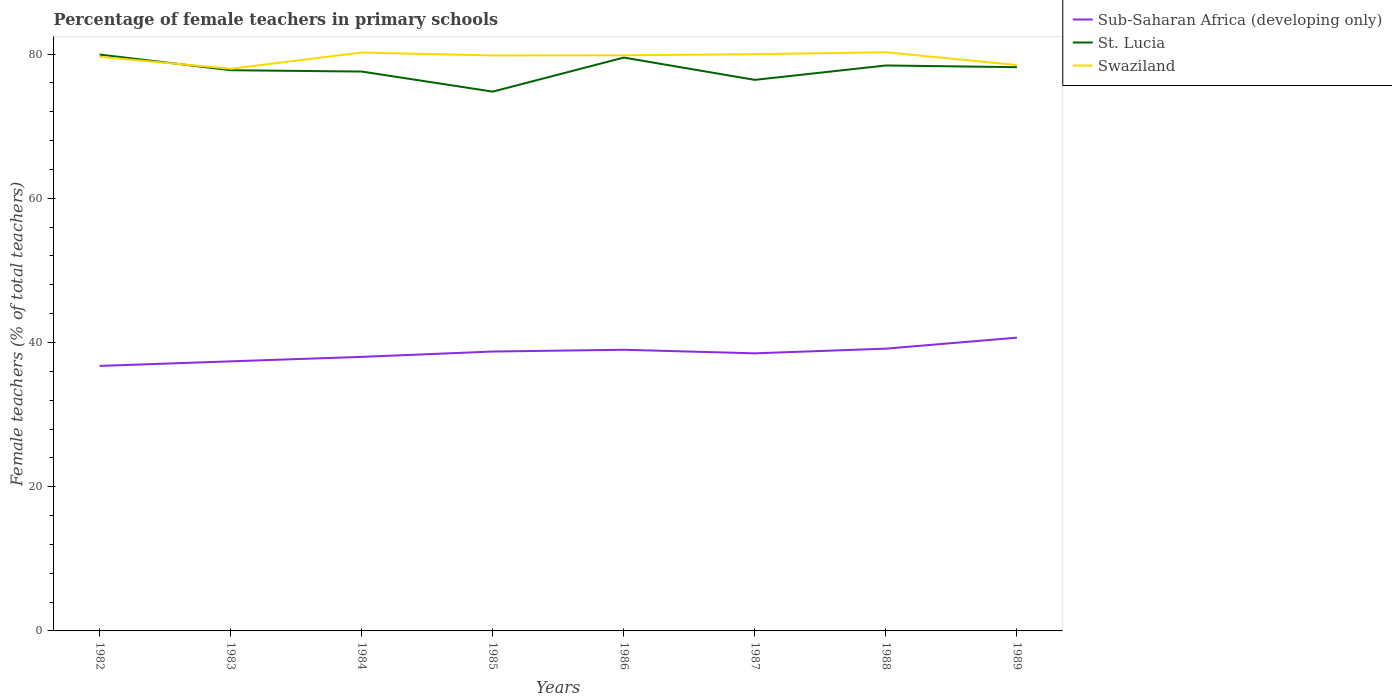Across all years, what is the maximum percentage of female teachers in St. Lucia?
Your response must be concise. 74.8. In which year was the percentage of female teachers in St. Lucia maximum?
Your answer should be very brief. 1985. What is the total percentage of female teachers in Sub-Saharan Africa (developing only) in the graph?
Make the answer very short. -0.4. What is the difference between the highest and the second highest percentage of female teachers in St. Lucia?
Your answer should be very brief. 5.14. Is the percentage of female teachers in Sub-Saharan Africa (developing only) strictly greater than the percentage of female teachers in Swaziland over the years?
Your response must be concise. Yes. What is the difference between two consecutive major ticks on the Y-axis?
Provide a succinct answer. 20. Are the values on the major ticks of Y-axis written in scientific E-notation?
Offer a very short reply. No. How many legend labels are there?
Your response must be concise. 3. How are the legend labels stacked?
Give a very brief answer. Vertical. What is the title of the graph?
Provide a short and direct response. Percentage of female teachers in primary schools. Does "Guam" appear as one of the legend labels in the graph?
Provide a succinct answer. No. What is the label or title of the Y-axis?
Give a very brief answer. Female teachers (% of total teachers). What is the Female teachers (% of total teachers) of Sub-Saharan Africa (developing only) in 1982?
Your answer should be compact. 36.75. What is the Female teachers (% of total teachers) in St. Lucia in 1982?
Ensure brevity in your answer.  79.94. What is the Female teachers (% of total teachers) in Swaziland in 1982?
Your answer should be compact. 79.62. What is the Female teachers (% of total teachers) of Sub-Saharan Africa (developing only) in 1983?
Keep it short and to the point. 37.39. What is the Female teachers (% of total teachers) in St. Lucia in 1983?
Make the answer very short. 77.77. What is the Female teachers (% of total teachers) of Swaziland in 1983?
Your answer should be very brief. 77.97. What is the Female teachers (% of total teachers) of Sub-Saharan Africa (developing only) in 1984?
Your answer should be very brief. 38.01. What is the Female teachers (% of total teachers) of St. Lucia in 1984?
Give a very brief answer. 77.58. What is the Female teachers (% of total teachers) of Swaziland in 1984?
Your answer should be very brief. 80.22. What is the Female teachers (% of total teachers) in Sub-Saharan Africa (developing only) in 1985?
Ensure brevity in your answer.  38.75. What is the Female teachers (% of total teachers) of St. Lucia in 1985?
Provide a succinct answer. 74.8. What is the Female teachers (% of total teachers) of Swaziland in 1985?
Offer a terse response. 79.81. What is the Female teachers (% of total teachers) in Sub-Saharan Africa (developing only) in 1986?
Your response must be concise. 38.99. What is the Female teachers (% of total teachers) in St. Lucia in 1986?
Offer a very short reply. 79.52. What is the Female teachers (% of total teachers) of Swaziland in 1986?
Make the answer very short. 79.84. What is the Female teachers (% of total teachers) of Sub-Saharan Africa (developing only) in 1987?
Offer a terse response. 38.5. What is the Female teachers (% of total teachers) of St. Lucia in 1987?
Make the answer very short. 76.43. What is the Female teachers (% of total teachers) in Swaziland in 1987?
Your answer should be compact. 79.99. What is the Female teachers (% of total teachers) of Sub-Saharan Africa (developing only) in 1988?
Your answer should be compact. 39.15. What is the Female teachers (% of total teachers) in St. Lucia in 1988?
Offer a terse response. 78.42. What is the Female teachers (% of total teachers) of Swaziland in 1988?
Give a very brief answer. 80.26. What is the Female teachers (% of total teachers) in Sub-Saharan Africa (developing only) in 1989?
Give a very brief answer. 40.67. What is the Female teachers (% of total teachers) of St. Lucia in 1989?
Give a very brief answer. 78.19. What is the Female teachers (% of total teachers) in Swaziland in 1989?
Give a very brief answer. 78.49. Across all years, what is the maximum Female teachers (% of total teachers) of Sub-Saharan Africa (developing only)?
Your response must be concise. 40.67. Across all years, what is the maximum Female teachers (% of total teachers) of St. Lucia?
Offer a terse response. 79.94. Across all years, what is the maximum Female teachers (% of total teachers) in Swaziland?
Ensure brevity in your answer.  80.26. Across all years, what is the minimum Female teachers (% of total teachers) of Sub-Saharan Africa (developing only)?
Make the answer very short. 36.75. Across all years, what is the minimum Female teachers (% of total teachers) of St. Lucia?
Your response must be concise. 74.8. Across all years, what is the minimum Female teachers (% of total teachers) in Swaziland?
Your answer should be very brief. 77.97. What is the total Female teachers (% of total teachers) of Sub-Saharan Africa (developing only) in the graph?
Your answer should be compact. 308.22. What is the total Female teachers (% of total teachers) in St. Lucia in the graph?
Provide a succinct answer. 622.65. What is the total Female teachers (% of total teachers) in Swaziland in the graph?
Your response must be concise. 636.19. What is the difference between the Female teachers (% of total teachers) of Sub-Saharan Africa (developing only) in 1982 and that in 1983?
Ensure brevity in your answer.  -0.63. What is the difference between the Female teachers (% of total teachers) of St. Lucia in 1982 and that in 1983?
Ensure brevity in your answer.  2.17. What is the difference between the Female teachers (% of total teachers) of Swaziland in 1982 and that in 1983?
Make the answer very short. 1.65. What is the difference between the Female teachers (% of total teachers) in Sub-Saharan Africa (developing only) in 1982 and that in 1984?
Offer a terse response. -1.26. What is the difference between the Female teachers (% of total teachers) of St. Lucia in 1982 and that in 1984?
Provide a short and direct response. 2.36. What is the difference between the Female teachers (% of total teachers) of Swaziland in 1982 and that in 1984?
Ensure brevity in your answer.  -0.59. What is the difference between the Female teachers (% of total teachers) of Sub-Saharan Africa (developing only) in 1982 and that in 1985?
Ensure brevity in your answer.  -2. What is the difference between the Female teachers (% of total teachers) in St. Lucia in 1982 and that in 1985?
Provide a succinct answer. 5.14. What is the difference between the Female teachers (% of total teachers) of Swaziland in 1982 and that in 1985?
Make the answer very short. -0.19. What is the difference between the Female teachers (% of total teachers) in Sub-Saharan Africa (developing only) in 1982 and that in 1986?
Provide a succinct answer. -2.24. What is the difference between the Female teachers (% of total teachers) of St. Lucia in 1982 and that in 1986?
Give a very brief answer. 0.42. What is the difference between the Female teachers (% of total teachers) of Swaziland in 1982 and that in 1986?
Offer a terse response. -0.21. What is the difference between the Female teachers (% of total teachers) of Sub-Saharan Africa (developing only) in 1982 and that in 1987?
Give a very brief answer. -1.75. What is the difference between the Female teachers (% of total teachers) in St. Lucia in 1982 and that in 1987?
Your response must be concise. 3.51. What is the difference between the Female teachers (% of total teachers) of Swaziland in 1982 and that in 1987?
Offer a very short reply. -0.36. What is the difference between the Female teachers (% of total teachers) in Sub-Saharan Africa (developing only) in 1982 and that in 1988?
Your answer should be compact. -2.39. What is the difference between the Female teachers (% of total teachers) in St. Lucia in 1982 and that in 1988?
Offer a terse response. 1.52. What is the difference between the Female teachers (% of total teachers) in Swaziland in 1982 and that in 1988?
Your answer should be very brief. -0.63. What is the difference between the Female teachers (% of total teachers) of Sub-Saharan Africa (developing only) in 1982 and that in 1989?
Your answer should be very brief. -3.92. What is the difference between the Female teachers (% of total teachers) of St. Lucia in 1982 and that in 1989?
Provide a succinct answer. 1.75. What is the difference between the Female teachers (% of total teachers) in Swaziland in 1982 and that in 1989?
Your response must be concise. 1.14. What is the difference between the Female teachers (% of total teachers) in Sub-Saharan Africa (developing only) in 1983 and that in 1984?
Your response must be concise. -0.62. What is the difference between the Female teachers (% of total teachers) in St. Lucia in 1983 and that in 1984?
Your answer should be very brief. 0.18. What is the difference between the Female teachers (% of total teachers) of Swaziland in 1983 and that in 1984?
Make the answer very short. -2.25. What is the difference between the Female teachers (% of total teachers) of Sub-Saharan Africa (developing only) in 1983 and that in 1985?
Ensure brevity in your answer.  -1.36. What is the difference between the Female teachers (% of total teachers) of St. Lucia in 1983 and that in 1985?
Give a very brief answer. 2.97. What is the difference between the Female teachers (% of total teachers) in Swaziland in 1983 and that in 1985?
Provide a succinct answer. -1.84. What is the difference between the Female teachers (% of total teachers) of Sub-Saharan Africa (developing only) in 1983 and that in 1986?
Make the answer very short. -1.61. What is the difference between the Female teachers (% of total teachers) of St. Lucia in 1983 and that in 1986?
Keep it short and to the point. -1.75. What is the difference between the Female teachers (% of total teachers) of Swaziland in 1983 and that in 1986?
Ensure brevity in your answer.  -1.87. What is the difference between the Female teachers (% of total teachers) of Sub-Saharan Africa (developing only) in 1983 and that in 1987?
Your answer should be very brief. -1.11. What is the difference between the Female teachers (% of total teachers) of St. Lucia in 1983 and that in 1987?
Provide a short and direct response. 1.34. What is the difference between the Female teachers (% of total teachers) of Swaziland in 1983 and that in 1987?
Your answer should be very brief. -2.02. What is the difference between the Female teachers (% of total teachers) in Sub-Saharan Africa (developing only) in 1983 and that in 1988?
Give a very brief answer. -1.76. What is the difference between the Female teachers (% of total teachers) of St. Lucia in 1983 and that in 1988?
Keep it short and to the point. -0.66. What is the difference between the Female teachers (% of total teachers) in Swaziland in 1983 and that in 1988?
Offer a very short reply. -2.29. What is the difference between the Female teachers (% of total teachers) in Sub-Saharan Africa (developing only) in 1983 and that in 1989?
Keep it short and to the point. -3.29. What is the difference between the Female teachers (% of total teachers) in St. Lucia in 1983 and that in 1989?
Give a very brief answer. -0.42. What is the difference between the Female teachers (% of total teachers) in Swaziland in 1983 and that in 1989?
Give a very brief answer. -0.52. What is the difference between the Female teachers (% of total teachers) of Sub-Saharan Africa (developing only) in 1984 and that in 1985?
Your answer should be compact. -0.74. What is the difference between the Female teachers (% of total teachers) of St. Lucia in 1984 and that in 1985?
Give a very brief answer. 2.79. What is the difference between the Female teachers (% of total teachers) of Swaziland in 1984 and that in 1985?
Make the answer very short. 0.4. What is the difference between the Female teachers (% of total teachers) of Sub-Saharan Africa (developing only) in 1984 and that in 1986?
Give a very brief answer. -0.99. What is the difference between the Female teachers (% of total teachers) of St. Lucia in 1984 and that in 1986?
Offer a terse response. -1.94. What is the difference between the Female teachers (% of total teachers) of Swaziland in 1984 and that in 1986?
Provide a short and direct response. 0.38. What is the difference between the Female teachers (% of total teachers) in Sub-Saharan Africa (developing only) in 1984 and that in 1987?
Keep it short and to the point. -0.49. What is the difference between the Female teachers (% of total teachers) of St. Lucia in 1984 and that in 1987?
Offer a very short reply. 1.16. What is the difference between the Female teachers (% of total teachers) of Swaziland in 1984 and that in 1987?
Your answer should be compact. 0.23. What is the difference between the Female teachers (% of total teachers) in Sub-Saharan Africa (developing only) in 1984 and that in 1988?
Make the answer very short. -1.14. What is the difference between the Female teachers (% of total teachers) in St. Lucia in 1984 and that in 1988?
Ensure brevity in your answer.  -0.84. What is the difference between the Female teachers (% of total teachers) in Swaziland in 1984 and that in 1988?
Keep it short and to the point. -0.04. What is the difference between the Female teachers (% of total teachers) of Sub-Saharan Africa (developing only) in 1984 and that in 1989?
Ensure brevity in your answer.  -2.67. What is the difference between the Female teachers (% of total teachers) of St. Lucia in 1984 and that in 1989?
Keep it short and to the point. -0.61. What is the difference between the Female teachers (% of total teachers) of Swaziland in 1984 and that in 1989?
Provide a short and direct response. 1.73. What is the difference between the Female teachers (% of total teachers) of Sub-Saharan Africa (developing only) in 1985 and that in 1986?
Offer a very short reply. -0.24. What is the difference between the Female teachers (% of total teachers) of St. Lucia in 1985 and that in 1986?
Keep it short and to the point. -4.72. What is the difference between the Female teachers (% of total teachers) in Swaziland in 1985 and that in 1986?
Make the answer very short. -0.02. What is the difference between the Female teachers (% of total teachers) in Sub-Saharan Africa (developing only) in 1985 and that in 1987?
Provide a short and direct response. 0.25. What is the difference between the Female teachers (% of total teachers) in St. Lucia in 1985 and that in 1987?
Your answer should be compact. -1.63. What is the difference between the Female teachers (% of total teachers) in Swaziland in 1985 and that in 1987?
Offer a terse response. -0.17. What is the difference between the Female teachers (% of total teachers) in Sub-Saharan Africa (developing only) in 1985 and that in 1988?
Keep it short and to the point. -0.4. What is the difference between the Female teachers (% of total teachers) in St. Lucia in 1985 and that in 1988?
Provide a succinct answer. -3.63. What is the difference between the Female teachers (% of total teachers) of Swaziland in 1985 and that in 1988?
Your answer should be compact. -0.44. What is the difference between the Female teachers (% of total teachers) of Sub-Saharan Africa (developing only) in 1985 and that in 1989?
Offer a terse response. -1.92. What is the difference between the Female teachers (% of total teachers) in St. Lucia in 1985 and that in 1989?
Offer a terse response. -3.39. What is the difference between the Female teachers (% of total teachers) in Swaziland in 1985 and that in 1989?
Your response must be concise. 1.33. What is the difference between the Female teachers (% of total teachers) in Sub-Saharan Africa (developing only) in 1986 and that in 1987?
Offer a very short reply. 0.5. What is the difference between the Female teachers (% of total teachers) of St. Lucia in 1986 and that in 1987?
Provide a short and direct response. 3.09. What is the difference between the Female teachers (% of total teachers) of Swaziland in 1986 and that in 1987?
Offer a very short reply. -0.15. What is the difference between the Female teachers (% of total teachers) in Sub-Saharan Africa (developing only) in 1986 and that in 1988?
Make the answer very short. -0.15. What is the difference between the Female teachers (% of total teachers) in St. Lucia in 1986 and that in 1988?
Your answer should be very brief. 1.1. What is the difference between the Female teachers (% of total teachers) in Swaziland in 1986 and that in 1988?
Offer a very short reply. -0.42. What is the difference between the Female teachers (% of total teachers) in Sub-Saharan Africa (developing only) in 1986 and that in 1989?
Ensure brevity in your answer.  -1.68. What is the difference between the Female teachers (% of total teachers) of St. Lucia in 1986 and that in 1989?
Make the answer very short. 1.33. What is the difference between the Female teachers (% of total teachers) of Swaziland in 1986 and that in 1989?
Offer a terse response. 1.35. What is the difference between the Female teachers (% of total teachers) of Sub-Saharan Africa (developing only) in 1987 and that in 1988?
Offer a terse response. -0.65. What is the difference between the Female teachers (% of total teachers) in St. Lucia in 1987 and that in 1988?
Your answer should be very brief. -2. What is the difference between the Female teachers (% of total teachers) of Swaziland in 1987 and that in 1988?
Your answer should be very brief. -0.27. What is the difference between the Female teachers (% of total teachers) of Sub-Saharan Africa (developing only) in 1987 and that in 1989?
Offer a terse response. -2.17. What is the difference between the Female teachers (% of total teachers) of St. Lucia in 1987 and that in 1989?
Your answer should be compact. -1.76. What is the difference between the Female teachers (% of total teachers) of Swaziland in 1987 and that in 1989?
Provide a short and direct response. 1.5. What is the difference between the Female teachers (% of total teachers) in Sub-Saharan Africa (developing only) in 1988 and that in 1989?
Your answer should be compact. -1.53. What is the difference between the Female teachers (% of total teachers) of St. Lucia in 1988 and that in 1989?
Give a very brief answer. 0.24. What is the difference between the Female teachers (% of total teachers) of Swaziland in 1988 and that in 1989?
Offer a terse response. 1.77. What is the difference between the Female teachers (% of total teachers) in Sub-Saharan Africa (developing only) in 1982 and the Female teachers (% of total teachers) in St. Lucia in 1983?
Your response must be concise. -41.01. What is the difference between the Female teachers (% of total teachers) in Sub-Saharan Africa (developing only) in 1982 and the Female teachers (% of total teachers) in Swaziland in 1983?
Make the answer very short. -41.22. What is the difference between the Female teachers (% of total teachers) in St. Lucia in 1982 and the Female teachers (% of total teachers) in Swaziland in 1983?
Offer a terse response. 1.97. What is the difference between the Female teachers (% of total teachers) in Sub-Saharan Africa (developing only) in 1982 and the Female teachers (% of total teachers) in St. Lucia in 1984?
Make the answer very short. -40.83. What is the difference between the Female teachers (% of total teachers) of Sub-Saharan Africa (developing only) in 1982 and the Female teachers (% of total teachers) of Swaziland in 1984?
Offer a terse response. -43.46. What is the difference between the Female teachers (% of total teachers) in St. Lucia in 1982 and the Female teachers (% of total teachers) in Swaziland in 1984?
Your response must be concise. -0.28. What is the difference between the Female teachers (% of total teachers) in Sub-Saharan Africa (developing only) in 1982 and the Female teachers (% of total teachers) in St. Lucia in 1985?
Offer a terse response. -38.04. What is the difference between the Female teachers (% of total teachers) in Sub-Saharan Africa (developing only) in 1982 and the Female teachers (% of total teachers) in Swaziland in 1985?
Provide a succinct answer. -43.06. What is the difference between the Female teachers (% of total teachers) of St. Lucia in 1982 and the Female teachers (% of total teachers) of Swaziland in 1985?
Offer a terse response. 0.13. What is the difference between the Female teachers (% of total teachers) in Sub-Saharan Africa (developing only) in 1982 and the Female teachers (% of total teachers) in St. Lucia in 1986?
Offer a terse response. -42.77. What is the difference between the Female teachers (% of total teachers) in Sub-Saharan Africa (developing only) in 1982 and the Female teachers (% of total teachers) in Swaziland in 1986?
Your response must be concise. -43.08. What is the difference between the Female teachers (% of total teachers) in St. Lucia in 1982 and the Female teachers (% of total teachers) in Swaziland in 1986?
Your response must be concise. 0.1. What is the difference between the Female teachers (% of total teachers) of Sub-Saharan Africa (developing only) in 1982 and the Female teachers (% of total teachers) of St. Lucia in 1987?
Keep it short and to the point. -39.67. What is the difference between the Female teachers (% of total teachers) of Sub-Saharan Africa (developing only) in 1982 and the Female teachers (% of total teachers) of Swaziland in 1987?
Your answer should be compact. -43.23. What is the difference between the Female teachers (% of total teachers) of St. Lucia in 1982 and the Female teachers (% of total teachers) of Swaziland in 1987?
Offer a terse response. -0.05. What is the difference between the Female teachers (% of total teachers) in Sub-Saharan Africa (developing only) in 1982 and the Female teachers (% of total teachers) in St. Lucia in 1988?
Provide a short and direct response. -41.67. What is the difference between the Female teachers (% of total teachers) of Sub-Saharan Africa (developing only) in 1982 and the Female teachers (% of total teachers) of Swaziland in 1988?
Provide a succinct answer. -43.5. What is the difference between the Female teachers (% of total teachers) in St. Lucia in 1982 and the Female teachers (% of total teachers) in Swaziland in 1988?
Make the answer very short. -0.32. What is the difference between the Female teachers (% of total teachers) of Sub-Saharan Africa (developing only) in 1982 and the Female teachers (% of total teachers) of St. Lucia in 1989?
Provide a short and direct response. -41.43. What is the difference between the Female teachers (% of total teachers) of Sub-Saharan Africa (developing only) in 1982 and the Female teachers (% of total teachers) of Swaziland in 1989?
Ensure brevity in your answer.  -41.73. What is the difference between the Female teachers (% of total teachers) of St. Lucia in 1982 and the Female teachers (% of total teachers) of Swaziland in 1989?
Provide a succinct answer. 1.45. What is the difference between the Female teachers (% of total teachers) in Sub-Saharan Africa (developing only) in 1983 and the Female teachers (% of total teachers) in St. Lucia in 1984?
Give a very brief answer. -40.2. What is the difference between the Female teachers (% of total teachers) in Sub-Saharan Africa (developing only) in 1983 and the Female teachers (% of total teachers) in Swaziland in 1984?
Provide a succinct answer. -42.83. What is the difference between the Female teachers (% of total teachers) in St. Lucia in 1983 and the Female teachers (% of total teachers) in Swaziland in 1984?
Give a very brief answer. -2.45. What is the difference between the Female teachers (% of total teachers) in Sub-Saharan Africa (developing only) in 1983 and the Female teachers (% of total teachers) in St. Lucia in 1985?
Your response must be concise. -37.41. What is the difference between the Female teachers (% of total teachers) of Sub-Saharan Africa (developing only) in 1983 and the Female teachers (% of total teachers) of Swaziland in 1985?
Offer a terse response. -42.43. What is the difference between the Female teachers (% of total teachers) in St. Lucia in 1983 and the Female teachers (% of total teachers) in Swaziland in 1985?
Your response must be concise. -2.05. What is the difference between the Female teachers (% of total teachers) in Sub-Saharan Africa (developing only) in 1983 and the Female teachers (% of total teachers) in St. Lucia in 1986?
Provide a succinct answer. -42.13. What is the difference between the Female teachers (% of total teachers) of Sub-Saharan Africa (developing only) in 1983 and the Female teachers (% of total teachers) of Swaziland in 1986?
Keep it short and to the point. -42.45. What is the difference between the Female teachers (% of total teachers) in St. Lucia in 1983 and the Female teachers (% of total teachers) in Swaziland in 1986?
Your answer should be very brief. -2.07. What is the difference between the Female teachers (% of total teachers) of Sub-Saharan Africa (developing only) in 1983 and the Female teachers (% of total teachers) of St. Lucia in 1987?
Your answer should be compact. -39.04. What is the difference between the Female teachers (% of total teachers) of Sub-Saharan Africa (developing only) in 1983 and the Female teachers (% of total teachers) of Swaziland in 1987?
Make the answer very short. -42.6. What is the difference between the Female teachers (% of total teachers) in St. Lucia in 1983 and the Female teachers (% of total teachers) in Swaziland in 1987?
Keep it short and to the point. -2.22. What is the difference between the Female teachers (% of total teachers) in Sub-Saharan Africa (developing only) in 1983 and the Female teachers (% of total teachers) in St. Lucia in 1988?
Provide a short and direct response. -41.04. What is the difference between the Female teachers (% of total teachers) in Sub-Saharan Africa (developing only) in 1983 and the Female teachers (% of total teachers) in Swaziland in 1988?
Your answer should be very brief. -42.87. What is the difference between the Female teachers (% of total teachers) of St. Lucia in 1983 and the Female teachers (% of total teachers) of Swaziland in 1988?
Your answer should be compact. -2.49. What is the difference between the Female teachers (% of total teachers) of Sub-Saharan Africa (developing only) in 1983 and the Female teachers (% of total teachers) of St. Lucia in 1989?
Ensure brevity in your answer.  -40.8. What is the difference between the Female teachers (% of total teachers) of Sub-Saharan Africa (developing only) in 1983 and the Female teachers (% of total teachers) of Swaziland in 1989?
Give a very brief answer. -41.1. What is the difference between the Female teachers (% of total teachers) of St. Lucia in 1983 and the Female teachers (% of total teachers) of Swaziland in 1989?
Ensure brevity in your answer.  -0.72. What is the difference between the Female teachers (% of total teachers) of Sub-Saharan Africa (developing only) in 1984 and the Female teachers (% of total teachers) of St. Lucia in 1985?
Ensure brevity in your answer.  -36.79. What is the difference between the Female teachers (% of total teachers) in Sub-Saharan Africa (developing only) in 1984 and the Female teachers (% of total teachers) in Swaziland in 1985?
Provide a succinct answer. -41.81. What is the difference between the Female teachers (% of total teachers) in St. Lucia in 1984 and the Female teachers (% of total teachers) in Swaziland in 1985?
Your response must be concise. -2.23. What is the difference between the Female teachers (% of total teachers) in Sub-Saharan Africa (developing only) in 1984 and the Female teachers (% of total teachers) in St. Lucia in 1986?
Your answer should be compact. -41.51. What is the difference between the Female teachers (% of total teachers) in Sub-Saharan Africa (developing only) in 1984 and the Female teachers (% of total teachers) in Swaziland in 1986?
Offer a terse response. -41.83. What is the difference between the Female teachers (% of total teachers) of St. Lucia in 1984 and the Female teachers (% of total teachers) of Swaziland in 1986?
Your answer should be very brief. -2.25. What is the difference between the Female teachers (% of total teachers) in Sub-Saharan Africa (developing only) in 1984 and the Female teachers (% of total teachers) in St. Lucia in 1987?
Ensure brevity in your answer.  -38.42. What is the difference between the Female teachers (% of total teachers) of Sub-Saharan Africa (developing only) in 1984 and the Female teachers (% of total teachers) of Swaziland in 1987?
Give a very brief answer. -41.98. What is the difference between the Female teachers (% of total teachers) of St. Lucia in 1984 and the Female teachers (% of total teachers) of Swaziland in 1987?
Your answer should be compact. -2.4. What is the difference between the Female teachers (% of total teachers) in Sub-Saharan Africa (developing only) in 1984 and the Female teachers (% of total teachers) in St. Lucia in 1988?
Your answer should be compact. -40.41. What is the difference between the Female teachers (% of total teachers) of Sub-Saharan Africa (developing only) in 1984 and the Female teachers (% of total teachers) of Swaziland in 1988?
Offer a very short reply. -42.25. What is the difference between the Female teachers (% of total teachers) of St. Lucia in 1984 and the Female teachers (% of total teachers) of Swaziland in 1988?
Ensure brevity in your answer.  -2.67. What is the difference between the Female teachers (% of total teachers) of Sub-Saharan Africa (developing only) in 1984 and the Female teachers (% of total teachers) of St. Lucia in 1989?
Your answer should be compact. -40.18. What is the difference between the Female teachers (% of total teachers) of Sub-Saharan Africa (developing only) in 1984 and the Female teachers (% of total teachers) of Swaziland in 1989?
Give a very brief answer. -40.48. What is the difference between the Female teachers (% of total teachers) of St. Lucia in 1984 and the Female teachers (% of total teachers) of Swaziland in 1989?
Provide a short and direct response. -0.9. What is the difference between the Female teachers (% of total teachers) in Sub-Saharan Africa (developing only) in 1985 and the Female teachers (% of total teachers) in St. Lucia in 1986?
Offer a very short reply. -40.77. What is the difference between the Female teachers (% of total teachers) of Sub-Saharan Africa (developing only) in 1985 and the Female teachers (% of total teachers) of Swaziland in 1986?
Provide a short and direct response. -41.09. What is the difference between the Female teachers (% of total teachers) of St. Lucia in 1985 and the Female teachers (% of total teachers) of Swaziland in 1986?
Ensure brevity in your answer.  -5.04. What is the difference between the Female teachers (% of total teachers) in Sub-Saharan Africa (developing only) in 1985 and the Female teachers (% of total teachers) in St. Lucia in 1987?
Offer a terse response. -37.68. What is the difference between the Female teachers (% of total teachers) of Sub-Saharan Africa (developing only) in 1985 and the Female teachers (% of total teachers) of Swaziland in 1987?
Keep it short and to the point. -41.24. What is the difference between the Female teachers (% of total teachers) of St. Lucia in 1985 and the Female teachers (% of total teachers) of Swaziland in 1987?
Keep it short and to the point. -5.19. What is the difference between the Female teachers (% of total teachers) of Sub-Saharan Africa (developing only) in 1985 and the Female teachers (% of total teachers) of St. Lucia in 1988?
Offer a terse response. -39.67. What is the difference between the Female teachers (% of total teachers) of Sub-Saharan Africa (developing only) in 1985 and the Female teachers (% of total teachers) of Swaziland in 1988?
Your answer should be compact. -41.51. What is the difference between the Female teachers (% of total teachers) in St. Lucia in 1985 and the Female teachers (% of total teachers) in Swaziland in 1988?
Offer a very short reply. -5.46. What is the difference between the Female teachers (% of total teachers) of Sub-Saharan Africa (developing only) in 1985 and the Female teachers (% of total teachers) of St. Lucia in 1989?
Make the answer very short. -39.44. What is the difference between the Female teachers (% of total teachers) of Sub-Saharan Africa (developing only) in 1985 and the Female teachers (% of total teachers) of Swaziland in 1989?
Ensure brevity in your answer.  -39.74. What is the difference between the Female teachers (% of total teachers) in St. Lucia in 1985 and the Female teachers (% of total teachers) in Swaziland in 1989?
Provide a short and direct response. -3.69. What is the difference between the Female teachers (% of total teachers) in Sub-Saharan Africa (developing only) in 1986 and the Female teachers (% of total teachers) in St. Lucia in 1987?
Provide a succinct answer. -37.43. What is the difference between the Female teachers (% of total teachers) of Sub-Saharan Africa (developing only) in 1986 and the Female teachers (% of total teachers) of Swaziland in 1987?
Give a very brief answer. -40.99. What is the difference between the Female teachers (% of total teachers) in St. Lucia in 1986 and the Female teachers (% of total teachers) in Swaziland in 1987?
Offer a very short reply. -0.47. What is the difference between the Female teachers (% of total teachers) of Sub-Saharan Africa (developing only) in 1986 and the Female teachers (% of total teachers) of St. Lucia in 1988?
Your answer should be very brief. -39.43. What is the difference between the Female teachers (% of total teachers) of Sub-Saharan Africa (developing only) in 1986 and the Female teachers (% of total teachers) of Swaziland in 1988?
Offer a terse response. -41.26. What is the difference between the Female teachers (% of total teachers) in St. Lucia in 1986 and the Female teachers (% of total teachers) in Swaziland in 1988?
Give a very brief answer. -0.74. What is the difference between the Female teachers (% of total teachers) in Sub-Saharan Africa (developing only) in 1986 and the Female teachers (% of total teachers) in St. Lucia in 1989?
Provide a short and direct response. -39.19. What is the difference between the Female teachers (% of total teachers) in Sub-Saharan Africa (developing only) in 1986 and the Female teachers (% of total teachers) in Swaziland in 1989?
Your answer should be very brief. -39.49. What is the difference between the Female teachers (% of total teachers) of St. Lucia in 1986 and the Female teachers (% of total teachers) of Swaziland in 1989?
Ensure brevity in your answer.  1.03. What is the difference between the Female teachers (% of total teachers) in Sub-Saharan Africa (developing only) in 1987 and the Female teachers (% of total teachers) in St. Lucia in 1988?
Your response must be concise. -39.92. What is the difference between the Female teachers (% of total teachers) of Sub-Saharan Africa (developing only) in 1987 and the Female teachers (% of total teachers) of Swaziland in 1988?
Make the answer very short. -41.76. What is the difference between the Female teachers (% of total teachers) of St. Lucia in 1987 and the Female teachers (% of total teachers) of Swaziland in 1988?
Your answer should be very brief. -3.83. What is the difference between the Female teachers (% of total teachers) of Sub-Saharan Africa (developing only) in 1987 and the Female teachers (% of total teachers) of St. Lucia in 1989?
Offer a very short reply. -39.69. What is the difference between the Female teachers (% of total teachers) of Sub-Saharan Africa (developing only) in 1987 and the Female teachers (% of total teachers) of Swaziland in 1989?
Ensure brevity in your answer.  -39.99. What is the difference between the Female teachers (% of total teachers) of St. Lucia in 1987 and the Female teachers (% of total teachers) of Swaziland in 1989?
Keep it short and to the point. -2.06. What is the difference between the Female teachers (% of total teachers) of Sub-Saharan Africa (developing only) in 1988 and the Female teachers (% of total teachers) of St. Lucia in 1989?
Your answer should be very brief. -39.04. What is the difference between the Female teachers (% of total teachers) in Sub-Saharan Africa (developing only) in 1988 and the Female teachers (% of total teachers) in Swaziland in 1989?
Give a very brief answer. -39.34. What is the difference between the Female teachers (% of total teachers) in St. Lucia in 1988 and the Female teachers (% of total teachers) in Swaziland in 1989?
Make the answer very short. -0.06. What is the average Female teachers (% of total teachers) in Sub-Saharan Africa (developing only) per year?
Provide a succinct answer. 38.53. What is the average Female teachers (% of total teachers) of St. Lucia per year?
Give a very brief answer. 77.83. What is the average Female teachers (% of total teachers) in Swaziland per year?
Give a very brief answer. 79.52. In the year 1982, what is the difference between the Female teachers (% of total teachers) of Sub-Saharan Africa (developing only) and Female teachers (% of total teachers) of St. Lucia?
Keep it short and to the point. -43.19. In the year 1982, what is the difference between the Female teachers (% of total teachers) of Sub-Saharan Africa (developing only) and Female teachers (% of total teachers) of Swaziland?
Offer a very short reply. -42.87. In the year 1982, what is the difference between the Female teachers (% of total teachers) in St. Lucia and Female teachers (% of total teachers) in Swaziland?
Your response must be concise. 0.32. In the year 1983, what is the difference between the Female teachers (% of total teachers) in Sub-Saharan Africa (developing only) and Female teachers (% of total teachers) in St. Lucia?
Your answer should be compact. -40.38. In the year 1983, what is the difference between the Female teachers (% of total teachers) in Sub-Saharan Africa (developing only) and Female teachers (% of total teachers) in Swaziland?
Keep it short and to the point. -40.58. In the year 1983, what is the difference between the Female teachers (% of total teachers) of St. Lucia and Female teachers (% of total teachers) of Swaziland?
Give a very brief answer. -0.2. In the year 1984, what is the difference between the Female teachers (% of total teachers) in Sub-Saharan Africa (developing only) and Female teachers (% of total teachers) in St. Lucia?
Your response must be concise. -39.57. In the year 1984, what is the difference between the Female teachers (% of total teachers) of Sub-Saharan Africa (developing only) and Female teachers (% of total teachers) of Swaziland?
Give a very brief answer. -42.21. In the year 1984, what is the difference between the Female teachers (% of total teachers) in St. Lucia and Female teachers (% of total teachers) in Swaziland?
Ensure brevity in your answer.  -2.63. In the year 1985, what is the difference between the Female teachers (% of total teachers) in Sub-Saharan Africa (developing only) and Female teachers (% of total teachers) in St. Lucia?
Make the answer very short. -36.05. In the year 1985, what is the difference between the Female teachers (% of total teachers) of Sub-Saharan Africa (developing only) and Female teachers (% of total teachers) of Swaziland?
Provide a short and direct response. -41.06. In the year 1985, what is the difference between the Female teachers (% of total teachers) in St. Lucia and Female teachers (% of total teachers) in Swaziland?
Keep it short and to the point. -5.02. In the year 1986, what is the difference between the Female teachers (% of total teachers) in Sub-Saharan Africa (developing only) and Female teachers (% of total teachers) in St. Lucia?
Provide a succinct answer. -40.53. In the year 1986, what is the difference between the Female teachers (% of total teachers) of Sub-Saharan Africa (developing only) and Female teachers (% of total teachers) of Swaziland?
Keep it short and to the point. -40.84. In the year 1986, what is the difference between the Female teachers (% of total teachers) of St. Lucia and Female teachers (% of total teachers) of Swaziland?
Ensure brevity in your answer.  -0.32. In the year 1987, what is the difference between the Female teachers (% of total teachers) of Sub-Saharan Africa (developing only) and Female teachers (% of total teachers) of St. Lucia?
Your response must be concise. -37.93. In the year 1987, what is the difference between the Female teachers (% of total teachers) of Sub-Saharan Africa (developing only) and Female teachers (% of total teachers) of Swaziland?
Your response must be concise. -41.49. In the year 1987, what is the difference between the Female teachers (% of total teachers) of St. Lucia and Female teachers (% of total teachers) of Swaziland?
Ensure brevity in your answer.  -3.56. In the year 1988, what is the difference between the Female teachers (% of total teachers) in Sub-Saharan Africa (developing only) and Female teachers (% of total teachers) in St. Lucia?
Provide a succinct answer. -39.28. In the year 1988, what is the difference between the Female teachers (% of total teachers) in Sub-Saharan Africa (developing only) and Female teachers (% of total teachers) in Swaziland?
Provide a short and direct response. -41.11. In the year 1988, what is the difference between the Female teachers (% of total teachers) of St. Lucia and Female teachers (% of total teachers) of Swaziland?
Your response must be concise. -1.83. In the year 1989, what is the difference between the Female teachers (% of total teachers) of Sub-Saharan Africa (developing only) and Female teachers (% of total teachers) of St. Lucia?
Ensure brevity in your answer.  -37.51. In the year 1989, what is the difference between the Female teachers (% of total teachers) in Sub-Saharan Africa (developing only) and Female teachers (% of total teachers) in Swaziland?
Provide a short and direct response. -37.81. In the year 1989, what is the difference between the Female teachers (% of total teachers) of St. Lucia and Female teachers (% of total teachers) of Swaziland?
Your answer should be compact. -0.3. What is the ratio of the Female teachers (% of total teachers) of St. Lucia in 1982 to that in 1983?
Your response must be concise. 1.03. What is the ratio of the Female teachers (% of total teachers) in Swaziland in 1982 to that in 1983?
Your response must be concise. 1.02. What is the ratio of the Female teachers (% of total teachers) in Sub-Saharan Africa (developing only) in 1982 to that in 1984?
Give a very brief answer. 0.97. What is the ratio of the Female teachers (% of total teachers) in St. Lucia in 1982 to that in 1984?
Your answer should be compact. 1.03. What is the ratio of the Female teachers (% of total teachers) in Sub-Saharan Africa (developing only) in 1982 to that in 1985?
Provide a short and direct response. 0.95. What is the ratio of the Female teachers (% of total teachers) of St. Lucia in 1982 to that in 1985?
Provide a short and direct response. 1.07. What is the ratio of the Female teachers (% of total teachers) of Swaziland in 1982 to that in 1985?
Give a very brief answer. 1. What is the ratio of the Female teachers (% of total teachers) in Sub-Saharan Africa (developing only) in 1982 to that in 1986?
Provide a short and direct response. 0.94. What is the ratio of the Female teachers (% of total teachers) in St. Lucia in 1982 to that in 1986?
Provide a short and direct response. 1.01. What is the ratio of the Female teachers (% of total teachers) of Swaziland in 1982 to that in 1986?
Keep it short and to the point. 1. What is the ratio of the Female teachers (% of total teachers) in Sub-Saharan Africa (developing only) in 1982 to that in 1987?
Make the answer very short. 0.95. What is the ratio of the Female teachers (% of total teachers) in St. Lucia in 1982 to that in 1987?
Your answer should be very brief. 1.05. What is the ratio of the Female teachers (% of total teachers) of Sub-Saharan Africa (developing only) in 1982 to that in 1988?
Ensure brevity in your answer.  0.94. What is the ratio of the Female teachers (% of total teachers) of St. Lucia in 1982 to that in 1988?
Your answer should be very brief. 1.02. What is the ratio of the Female teachers (% of total teachers) of Swaziland in 1982 to that in 1988?
Your response must be concise. 0.99. What is the ratio of the Female teachers (% of total teachers) in Sub-Saharan Africa (developing only) in 1982 to that in 1989?
Your response must be concise. 0.9. What is the ratio of the Female teachers (% of total teachers) of St. Lucia in 1982 to that in 1989?
Make the answer very short. 1.02. What is the ratio of the Female teachers (% of total teachers) in Swaziland in 1982 to that in 1989?
Provide a succinct answer. 1.01. What is the ratio of the Female teachers (% of total teachers) in Sub-Saharan Africa (developing only) in 1983 to that in 1984?
Your response must be concise. 0.98. What is the ratio of the Female teachers (% of total teachers) of Sub-Saharan Africa (developing only) in 1983 to that in 1985?
Provide a short and direct response. 0.96. What is the ratio of the Female teachers (% of total teachers) in St. Lucia in 1983 to that in 1985?
Offer a terse response. 1.04. What is the ratio of the Female teachers (% of total teachers) of Swaziland in 1983 to that in 1985?
Provide a succinct answer. 0.98. What is the ratio of the Female teachers (% of total teachers) of Sub-Saharan Africa (developing only) in 1983 to that in 1986?
Make the answer very short. 0.96. What is the ratio of the Female teachers (% of total teachers) of St. Lucia in 1983 to that in 1986?
Offer a terse response. 0.98. What is the ratio of the Female teachers (% of total teachers) of Swaziland in 1983 to that in 1986?
Make the answer very short. 0.98. What is the ratio of the Female teachers (% of total teachers) of Sub-Saharan Africa (developing only) in 1983 to that in 1987?
Offer a terse response. 0.97. What is the ratio of the Female teachers (% of total teachers) in St. Lucia in 1983 to that in 1987?
Give a very brief answer. 1.02. What is the ratio of the Female teachers (% of total teachers) of Swaziland in 1983 to that in 1987?
Provide a succinct answer. 0.97. What is the ratio of the Female teachers (% of total teachers) in Sub-Saharan Africa (developing only) in 1983 to that in 1988?
Keep it short and to the point. 0.95. What is the ratio of the Female teachers (% of total teachers) in St. Lucia in 1983 to that in 1988?
Your answer should be very brief. 0.99. What is the ratio of the Female teachers (% of total teachers) in Swaziland in 1983 to that in 1988?
Your answer should be very brief. 0.97. What is the ratio of the Female teachers (% of total teachers) in Sub-Saharan Africa (developing only) in 1983 to that in 1989?
Ensure brevity in your answer.  0.92. What is the ratio of the Female teachers (% of total teachers) in Swaziland in 1983 to that in 1989?
Provide a short and direct response. 0.99. What is the ratio of the Female teachers (% of total teachers) of Sub-Saharan Africa (developing only) in 1984 to that in 1985?
Offer a very short reply. 0.98. What is the ratio of the Female teachers (% of total teachers) in St. Lucia in 1984 to that in 1985?
Provide a short and direct response. 1.04. What is the ratio of the Female teachers (% of total teachers) of Sub-Saharan Africa (developing only) in 1984 to that in 1986?
Make the answer very short. 0.97. What is the ratio of the Female teachers (% of total teachers) in St. Lucia in 1984 to that in 1986?
Ensure brevity in your answer.  0.98. What is the ratio of the Female teachers (% of total teachers) in Swaziland in 1984 to that in 1986?
Your answer should be compact. 1. What is the ratio of the Female teachers (% of total teachers) in Sub-Saharan Africa (developing only) in 1984 to that in 1987?
Make the answer very short. 0.99. What is the ratio of the Female teachers (% of total teachers) in St. Lucia in 1984 to that in 1987?
Provide a short and direct response. 1.02. What is the ratio of the Female teachers (% of total teachers) in Swaziland in 1984 to that in 1987?
Provide a succinct answer. 1. What is the ratio of the Female teachers (% of total teachers) of Sub-Saharan Africa (developing only) in 1984 to that in 1988?
Your answer should be very brief. 0.97. What is the ratio of the Female teachers (% of total teachers) of St. Lucia in 1984 to that in 1988?
Give a very brief answer. 0.99. What is the ratio of the Female teachers (% of total teachers) of Sub-Saharan Africa (developing only) in 1984 to that in 1989?
Give a very brief answer. 0.93. What is the ratio of the Female teachers (% of total teachers) of St. Lucia in 1984 to that in 1989?
Your response must be concise. 0.99. What is the ratio of the Female teachers (% of total teachers) in Swaziland in 1984 to that in 1989?
Keep it short and to the point. 1.02. What is the ratio of the Female teachers (% of total teachers) in Sub-Saharan Africa (developing only) in 1985 to that in 1986?
Your answer should be very brief. 0.99. What is the ratio of the Female teachers (% of total teachers) of St. Lucia in 1985 to that in 1986?
Your response must be concise. 0.94. What is the ratio of the Female teachers (% of total teachers) of Swaziland in 1985 to that in 1986?
Your answer should be very brief. 1. What is the ratio of the Female teachers (% of total teachers) in Sub-Saharan Africa (developing only) in 1985 to that in 1987?
Your answer should be compact. 1.01. What is the ratio of the Female teachers (% of total teachers) of St. Lucia in 1985 to that in 1987?
Offer a terse response. 0.98. What is the ratio of the Female teachers (% of total teachers) of Swaziland in 1985 to that in 1987?
Offer a terse response. 1. What is the ratio of the Female teachers (% of total teachers) of St. Lucia in 1985 to that in 1988?
Offer a terse response. 0.95. What is the ratio of the Female teachers (% of total teachers) of Sub-Saharan Africa (developing only) in 1985 to that in 1989?
Offer a very short reply. 0.95. What is the ratio of the Female teachers (% of total teachers) in St. Lucia in 1985 to that in 1989?
Provide a short and direct response. 0.96. What is the ratio of the Female teachers (% of total teachers) of Swaziland in 1985 to that in 1989?
Your answer should be compact. 1.02. What is the ratio of the Female teachers (% of total teachers) in Sub-Saharan Africa (developing only) in 1986 to that in 1987?
Keep it short and to the point. 1.01. What is the ratio of the Female teachers (% of total teachers) of St. Lucia in 1986 to that in 1987?
Your answer should be very brief. 1.04. What is the ratio of the Female teachers (% of total teachers) in Sub-Saharan Africa (developing only) in 1986 to that in 1989?
Ensure brevity in your answer.  0.96. What is the ratio of the Female teachers (% of total teachers) in St. Lucia in 1986 to that in 1989?
Make the answer very short. 1.02. What is the ratio of the Female teachers (% of total teachers) in Swaziland in 1986 to that in 1989?
Provide a succinct answer. 1.02. What is the ratio of the Female teachers (% of total teachers) in Sub-Saharan Africa (developing only) in 1987 to that in 1988?
Your answer should be compact. 0.98. What is the ratio of the Female teachers (% of total teachers) of St. Lucia in 1987 to that in 1988?
Give a very brief answer. 0.97. What is the ratio of the Female teachers (% of total teachers) of Swaziland in 1987 to that in 1988?
Ensure brevity in your answer.  1. What is the ratio of the Female teachers (% of total teachers) in Sub-Saharan Africa (developing only) in 1987 to that in 1989?
Provide a succinct answer. 0.95. What is the ratio of the Female teachers (% of total teachers) in St. Lucia in 1987 to that in 1989?
Give a very brief answer. 0.98. What is the ratio of the Female teachers (% of total teachers) in Swaziland in 1987 to that in 1989?
Your answer should be compact. 1.02. What is the ratio of the Female teachers (% of total teachers) of Sub-Saharan Africa (developing only) in 1988 to that in 1989?
Make the answer very short. 0.96. What is the ratio of the Female teachers (% of total teachers) of Swaziland in 1988 to that in 1989?
Your answer should be very brief. 1.02. What is the difference between the highest and the second highest Female teachers (% of total teachers) in Sub-Saharan Africa (developing only)?
Keep it short and to the point. 1.53. What is the difference between the highest and the second highest Female teachers (% of total teachers) of St. Lucia?
Your response must be concise. 0.42. What is the difference between the highest and the second highest Female teachers (% of total teachers) of Swaziland?
Your answer should be very brief. 0.04. What is the difference between the highest and the lowest Female teachers (% of total teachers) in Sub-Saharan Africa (developing only)?
Make the answer very short. 3.92. What is the difference between the highest and the lowest Female teachers (% of total teachers) in St. Lucia?
Offer a very short reply. 5.14. What is the difference between the highest and the lowest Female teachers (% of total teachers) of Swaziland?
Provide a short and direct response. 2.29. 